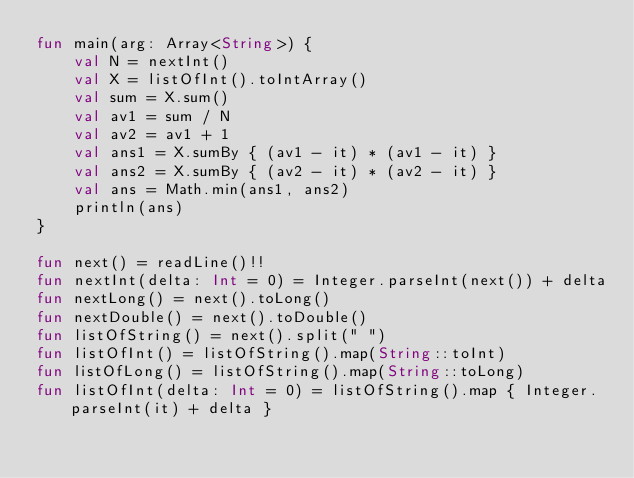Convert code to text. <code><loc_0><loc_0><loc_500><loc_500><_Kotlin_>fun main(arg: Array<String>) {
    val N = nextInt()
    val X = listOfInt().toIntArray()
    val sum = X.sum()
    val av1 = sum / N
    val av2 = av1 + 1
    val ans1 = X.sumBy { (av1 - it) * (av1 - it) }
    val ans2 = X.sumBy { (av2 - it) * (av2 - it) }
    val ans = Math.min(ans1, ans2)
    println(ans)
}

fun next() = readLine()!!
fun nextInt(delta: Int = 0) = Integer.parseInt(next()) + delta
fun nextLong() = next().toLong()
fun nextDouble() = next().toDouble()
fun listOfString() = next().split(" ")
fun listOfInt() = listOfString().map(String::toInt)
fun listOfLong() = listOfString().map(String::toLong)
fun listOfInt(delta: Int = 0) = listOfString().map { Integer.parseInt(it) + delta }

</code> 